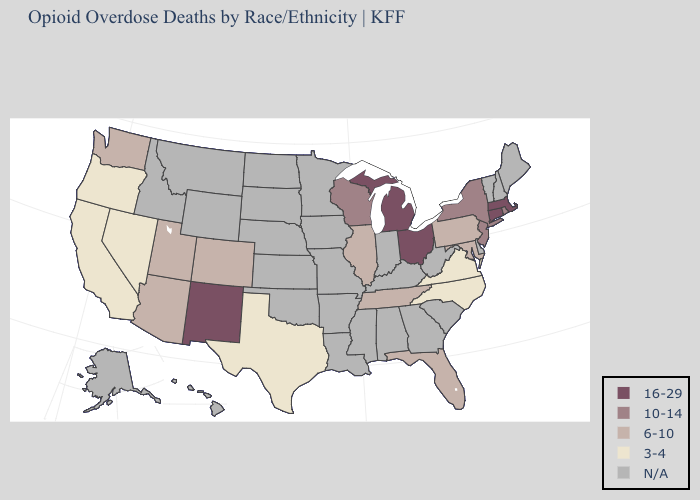What is the value of Connecticut?
Quick response, please. 16-29. Name the states that have a value in the range 16-29?
Concise answer only. Connecticut, Massachusetts, Michigan, New Mexico, Ohio. Is the legend a continuous bar?
Concise answer only. No. Does Michigan have the highest value in the MidWest?
Concise answer only. Yes. Does Michigan have the highest value in the USA?
Write a very short answer. Yes. What is the lowest value in the South?
Write a very short answer. 3-4. What is the highest value in the South ?
Concise answer only. 6-10. What is the lowest value in states that border Alabama?
Keep it brief. 6-10. What is the highest value in states that border Connecticut?
Short answer required. 16-29. Among the states that border North Carolina , which have the highest value?
Answer briefly. Tennessee. What is the highest value in the MidWest ?
Write a very short answer. 16-29. Name the states that have a value in the range 6-10?
Write a very short answer. Arizona, Colorado, Florida, Illinois, Maryland, Pennsylvania, Tennessee, Utah, Washington. Which states have the lowest value in the South?
Concise answer only. North Carolina, Texas, Virginia. What is the highest value in states that border Arizona?
Concise answer only. 16-29. 